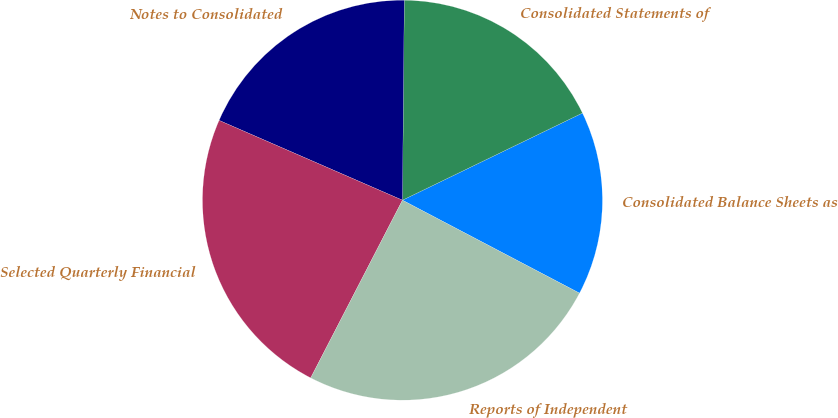<chart> <loc_0><loc_0><loc_500><loc_500><pie_chart><fcel>Consolidated Balance Sheets as<fcel>Consolidated Statements of<fcel>Notes to Consolidated<fcel>Selected Quarterly Financial<fcel>Reports of Independent<nl><fcel>14.87%<fcel>17.68%<fcel>18.61%<fcel>23.95%<fcel>24.89%<nl></chart> 